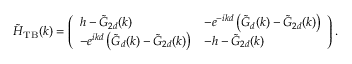Convert formula to latex. <formula><loc_0><loc_0><loc_500><loc_500>\tilde { H } _ { T B } ( k ) = \left ( \begin{array} { l l } { h - \tilde { G } _ { 2 d } ( k ) } & { - e ^ { - i k d } \left ( \tilde { G } _ { d } ( k ) - \tilde { G } _ { 2 d } ( k ) \right ) } \\ { - e ^ { i k d } \left ( \tilde { G } _ { d } ( k ) - \tilde { G } _ { 2 d } ( k ) \right ) } & { - h - \tilde { G } _ { 2 d } ( k ) } \end{array} \right ) .</formula> 